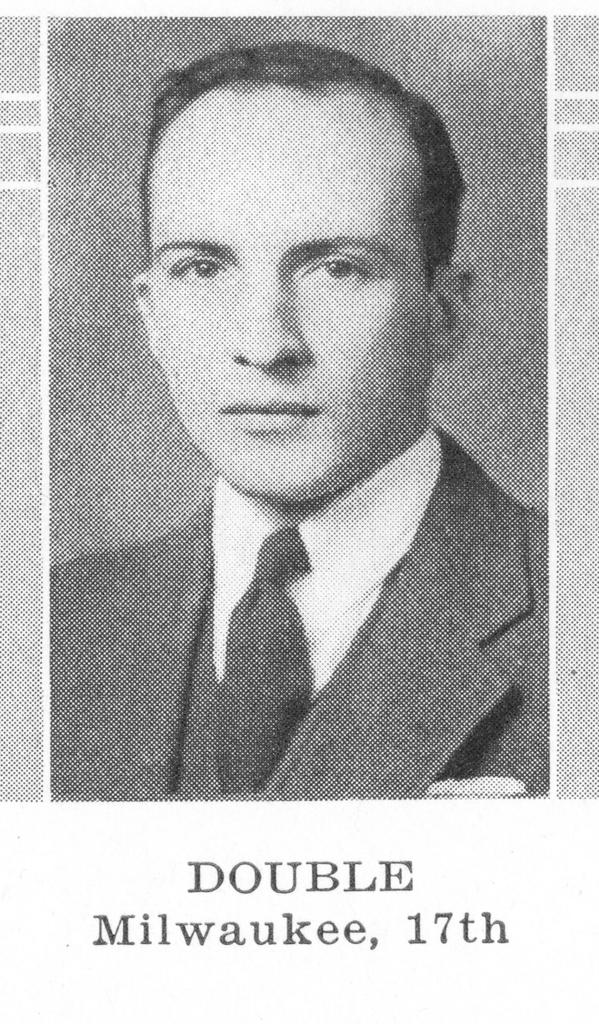Who is present in the image? There is a man in the image. What is the man wearing around his neck? The man is wearing a tie. What type of clothing is the man wearing on his upper body? The man is wearing a shirt and a coat. What is the color scheme of the image? The image is in black and white color. What type of truck is visible in the image? There is no truck present in the image. What appliance is being used by the man in the image? There is no appliance visible in the image. 